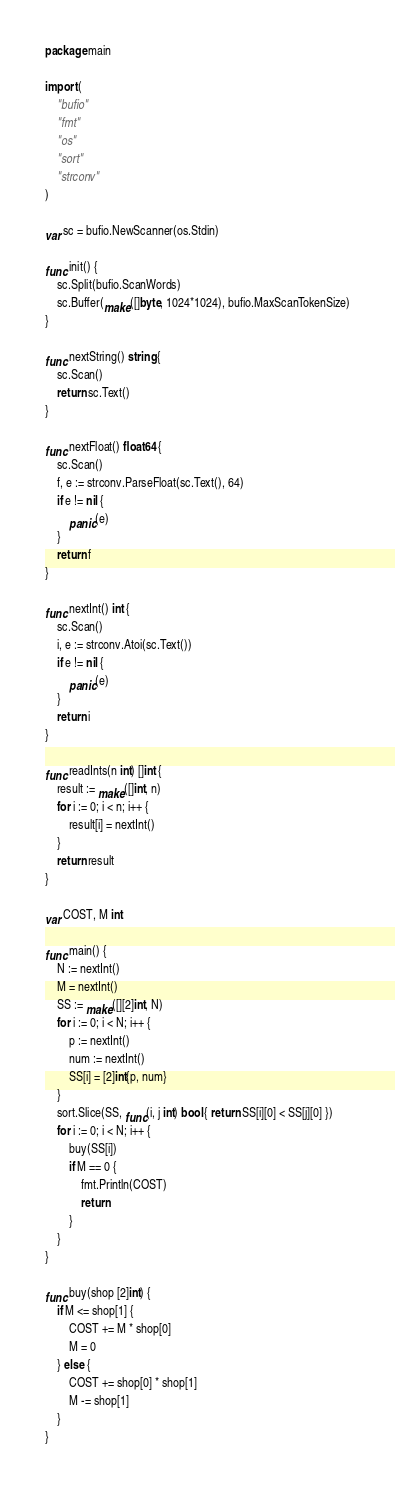<code> <loc_0><loc_0><loc_500><loc_500><_Go_>package main

import (
	"bufio"
	"fmt"
	"os"
	"sort"
	"strconv"
)

var sc = bufio.NewScanner(os.Stdin)

func init() {
	sc.Split(bufio.ScanWords)
	sc.Buffer(make([]byte, 1024*1024), bufio.MaxScanTokenSize)
}

func nextString() string {
	sc.Scan()
	return sc.Text()
}

func nextFloat() float64 {
	sc.Scan()
	f, e := strconv.ParseFloat(sc.Text(), 64)
	if e != nil {
		panic(e)
	}
	return f
}

func nextInt() int {
	sc.Scan()
	i, e := strconv.Atoi(sc.Text())
	if e != nil {
		panic(e)
	}
	return i
}

func readInts(n int) []int {
	result := make([]int, n)
	for i := 0; i < n; i++ {
		result[i] = nextInt()
	}
	return result
}

var COST, M int

func main() {
	N := nextInt()
	M = nextInt()
	SS := make([][2]int, N)
	for i := 0; i < N; i++ {
		p := nextInt()
		num := nextInt()
		SS[i] = [2]int{p, num}
	}
	sort.Slice(SS, func(i, j int) bool { return SS[i][0] < SS[j][0] })
	for i := 0; i < N; i++ {
		buy(SS[i])
		if M == 0 {
			fmt.Println(COST)
			return
		}
	}
}

func buy(shop [2]int) {
	if M <= shop[1] {
		COST += M * shop[0]
		M = 0
	} else {
		COST += shop[0] * shop[1]
		M -= shop[1]
	}
}
</code> 